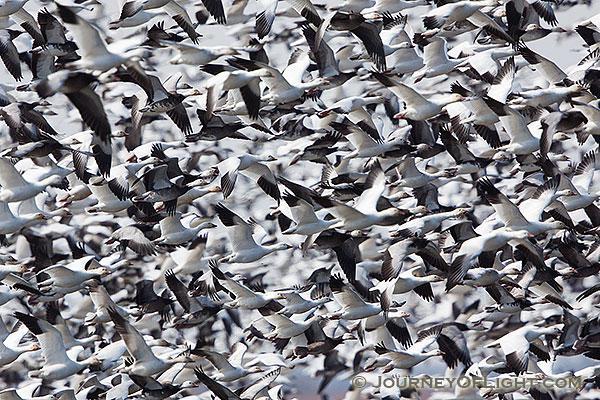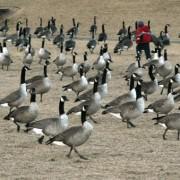The first image is the image on the left, the second image is the image on the right. Considering the images on both sides, is "There is at least one person in one of the images." valid? Answer yes or no. Yes. 